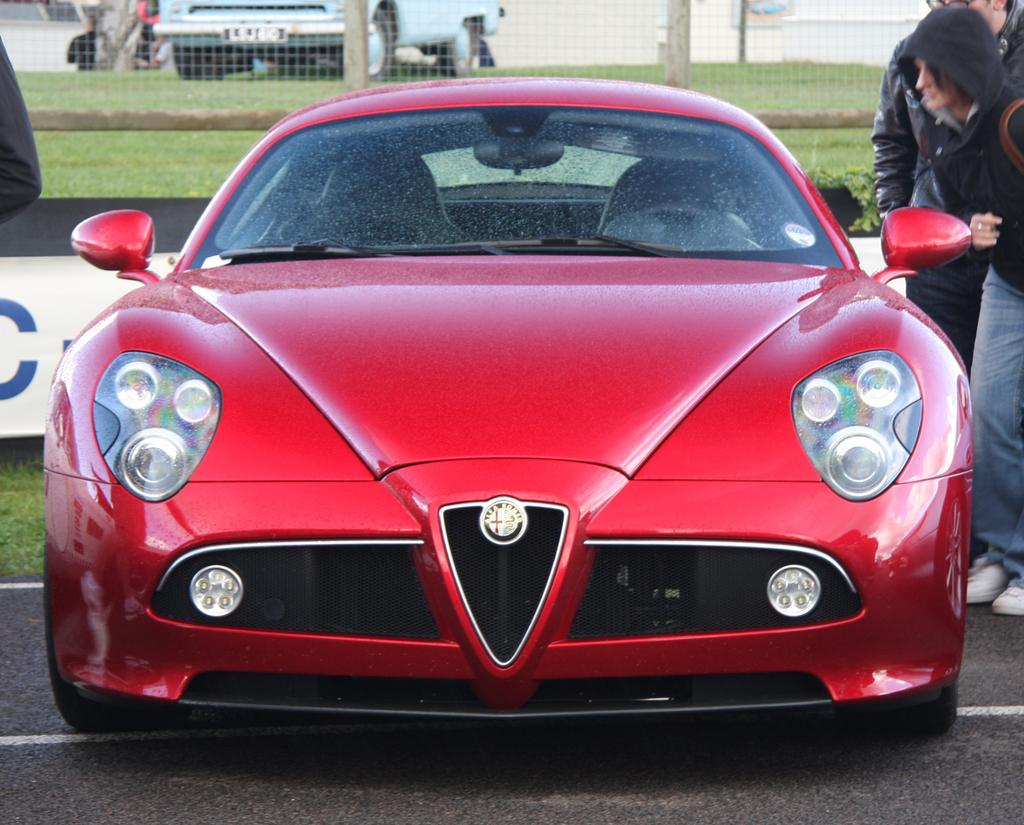What color is the car in the image? The car in the image is red. Where is the car located in the image? The car is on the road. Are there any people near the car in the image? Yes, there are people standing beside the car. What type of haircut does the monkey have in the image? There is no monkey present in the image, so it is not possible to answer that question. 